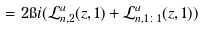Convert formula to latex. <formula><loc_0><loc_0><loc_500><loc_500>= 2 \i i ( { \mathcal { L } } ^ { a } _ { n , 2 } ( z , 1 ) + { \mathcal { L } } ^ { a } _ { n , 1 \colon 1 } ( z , 1 ) )</formula> 